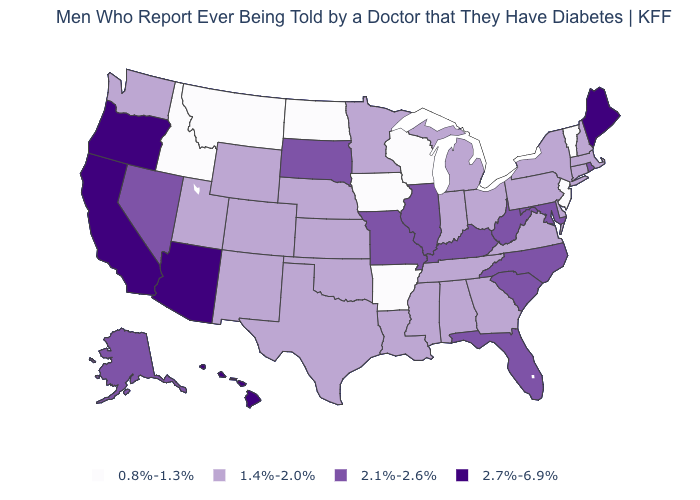Name the states that have a value in the range 2.1%-2.6%?
Answer briefly. Alaska, Florida, Illinois, Kentucky, Maryland, Missouri, Nevada, North Carolina, Rhode Island, South Carolina, South Dakota, West Virginia. What is the value of Maine?
Quick response, please. 2.7%-6.9%. Does South Carolina have a higher value than Utah?
Concise answer only. Yes. Among the states that border Virginia , does Maryland have the highest value?
Write a very short answer. Yes. Does the first symbol in the legend represent the smallest category?
Be succinct. Yes. How many symbols are there in the legend?
Short answer required. 4. What is the highest value in states that border Mississippi?
Be succinct. 1.4%-2.0%. Among the states that border Maryland , which have the highest value?
Be succinct. West Virginia. Which states have the highest value in the USA?
Quick response, please. Arizona, California, Hawaii, Maine, Oregon. What is the value of South Dakota?
Keep it brief. 2.1%-2.6%. Name the states that have a value in the range 2.7%-6.9%?
Give a very brief answer. Arizona, California, Hawaii, Maine, Oregon. Does Montana have the same value as North Dakota?
Write a very short answer. Yes. Does Vermont have the lowest value in the USA?
Concise answer only. Yes. What is the highest value in the USA?
Be succinct. 2.7%-6.9%. Does Texas have the lowest value in the USA?
Quick response, please. No. 